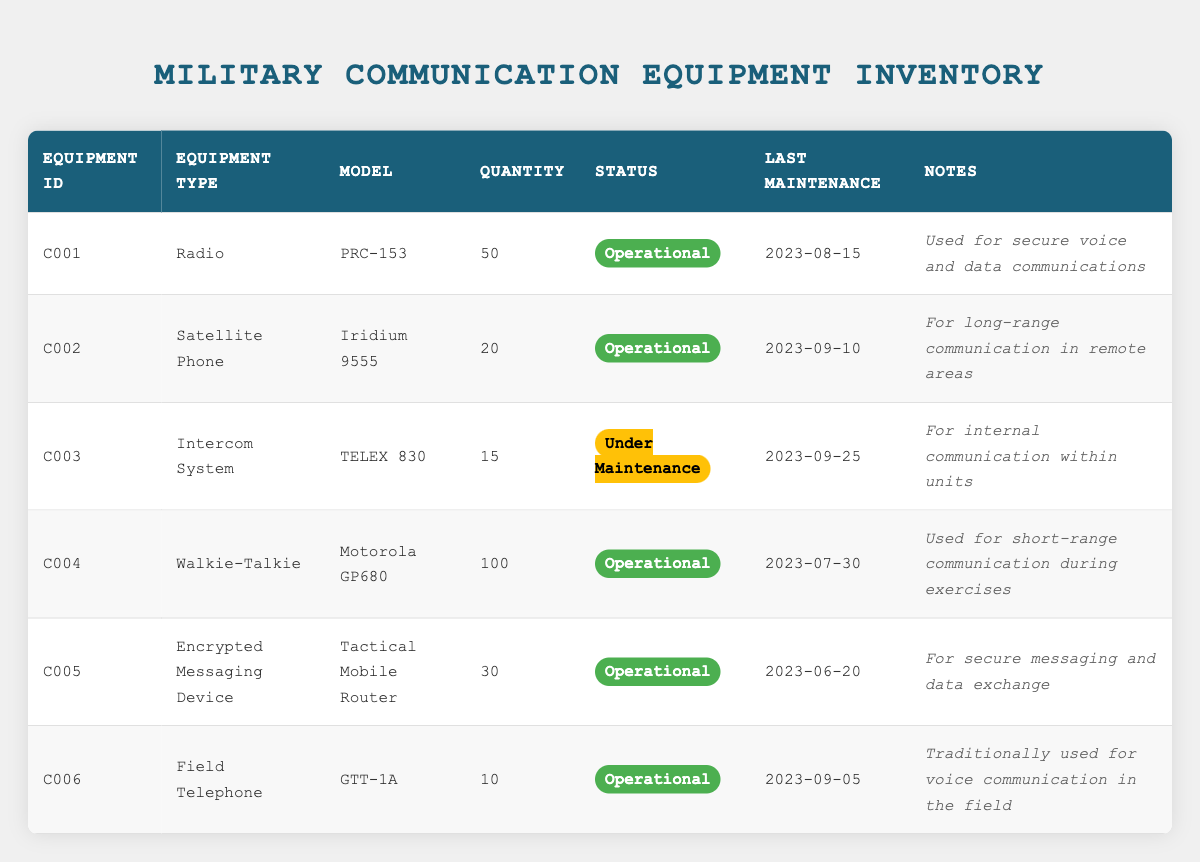What is the total quantity of operational communication equipment? To find the total quantity of operational communication equipment, we look for equipment with the status 'Operational' and sum their quantities: 50 (Radio) + 20 (Satellite Phone) + 100 (Walkie-Talkie) + 30 (Encrypted Messaging Device) + 10 (Field Telephone) = 210. The only equipment that is not operational is the Intercom System, which has 15 units.
Answer: 210 How many different types of communication equipment are currently under maintenance? We check the status of each piece of equipment in the table. There is one piece of equipment, the Intercom System (TELEX 830), that is marked as 'Under Maintenance'. Therefore, only one type is currently under maintenance.
Answer: 1 What is the last maintenance date for the Walkie-Talkie model? The last maintenance date can be found directly in the table by locating the row for the Walkie-Talkie model (Motorola GP680). The last maintenance date for this equipment is 2023-07-30.
Answer: 2023-07-30 Is the Encrypted Messaging Device the only piece of equipment with 30 units? We look for other pieces of equipment with a quantity of 30. The only equipment with a quantity of 30 is the Encrypted Messaging Device (Tactical Mobile Router), as no other equipment matches this quantity. Therefore, it is indeed the only piece with 30 units.
Answer: Yes What percentage of the total inventory is operational? To find the percentage of operational inventory, first, sum the total quantity of all equipment: 50 (Radio) + 20 (Satellite Phone) + 15 (Intercom System) + 100 (Walkie-Talkie) + 30 (Encrypted Messaging Device) + 10 (Field Telephone) = 225. Then, the number of operational equipment is 210. The formula for percentage is (Operational Quantity / Total Quantity) * 100 = (210 / 225) * 100 ≈ 93.33%.
Answer: Approximately 93.33% Which equipment has the shortest maintenance interval since the last maintenance? To determine the shortest maintenance interval, we calculate the difference between today's date and the last maintenance date for each operational equipment. The last maintenance dates are: PRC-153 (2023-08-15), Iridium 9555 (2023-09-10), Motorola GP680 (2023-07-30), Tactical Mobile Router (2023-06-20), GTT-1A (2023-09-05). The most recent maintenance was for the Iridium 9555 on 2023-09-10, making it the equipment with the shortest maintenance interval.
Answer: Iridium 9555 How many units of the Intercom System are involved in internal communication within units? The Inventory table specifies that there are 15 units of the Intercom System (TELEX 830) that are used for internal communication within units. Since the question directly inquires about a specific equipment model, we can simply refer to the quantity stated in the table.
Answer: 15 What is the total value in terms of quantity of all communication devices? To find the total value in terms of quantity of all devices, we add the quantities of each piece of equipment together: 50 (Radio) + 20 (Satellite Phone) + 15 (Intercom System) + 100 (Walkie-Talkie) + 30 (Encrypted Messaging Device) + 10 (Field Telephone) = 225. This sum represents the total number of communication devices in the inventory.
Answer: 225 How many communication devices are solely used for secure messaging and long-range communication? We analyze the notes provided for each piece of equipment. The Encrypted Messaging Device (Tactical Mobile Router) is noted for secure messaging, and the Satellite Phone (Iridium 9555) is noted for long-range communication. Counting these devices gives us 2 that are specified for these purposes.
Answer: 2 